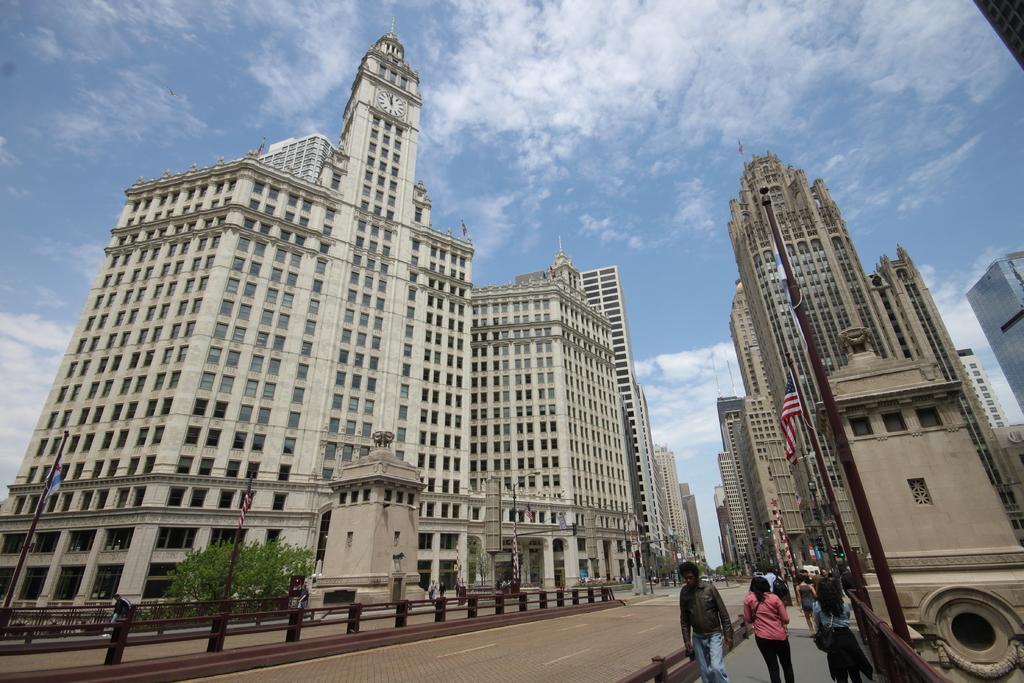Could you give a brief overview of what you see in this image? In this image we can see a group of buildings. In front of the buildings we can see a few trees and persons. At the bottom we can see barriers and poles with flags. At the top we can see the sky. 